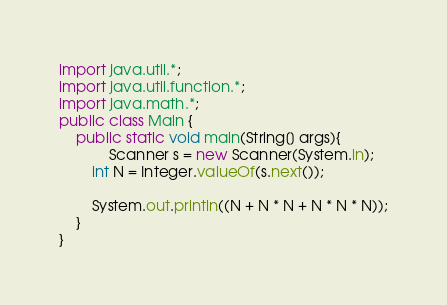Convert code to text. <code><loc_0><loc_0><loc_500><loc_500><_Java_>import java.util.*;
import java.util.function.*;
import java.math.*;
public class Main {
    public static void main(String[] args){
			Scanner s = new Scanner(System.in);
		int N = Integer.valueOf(s.next());
		
		System.out.println((N + N * N + N * N * N));
	}
}</code> 